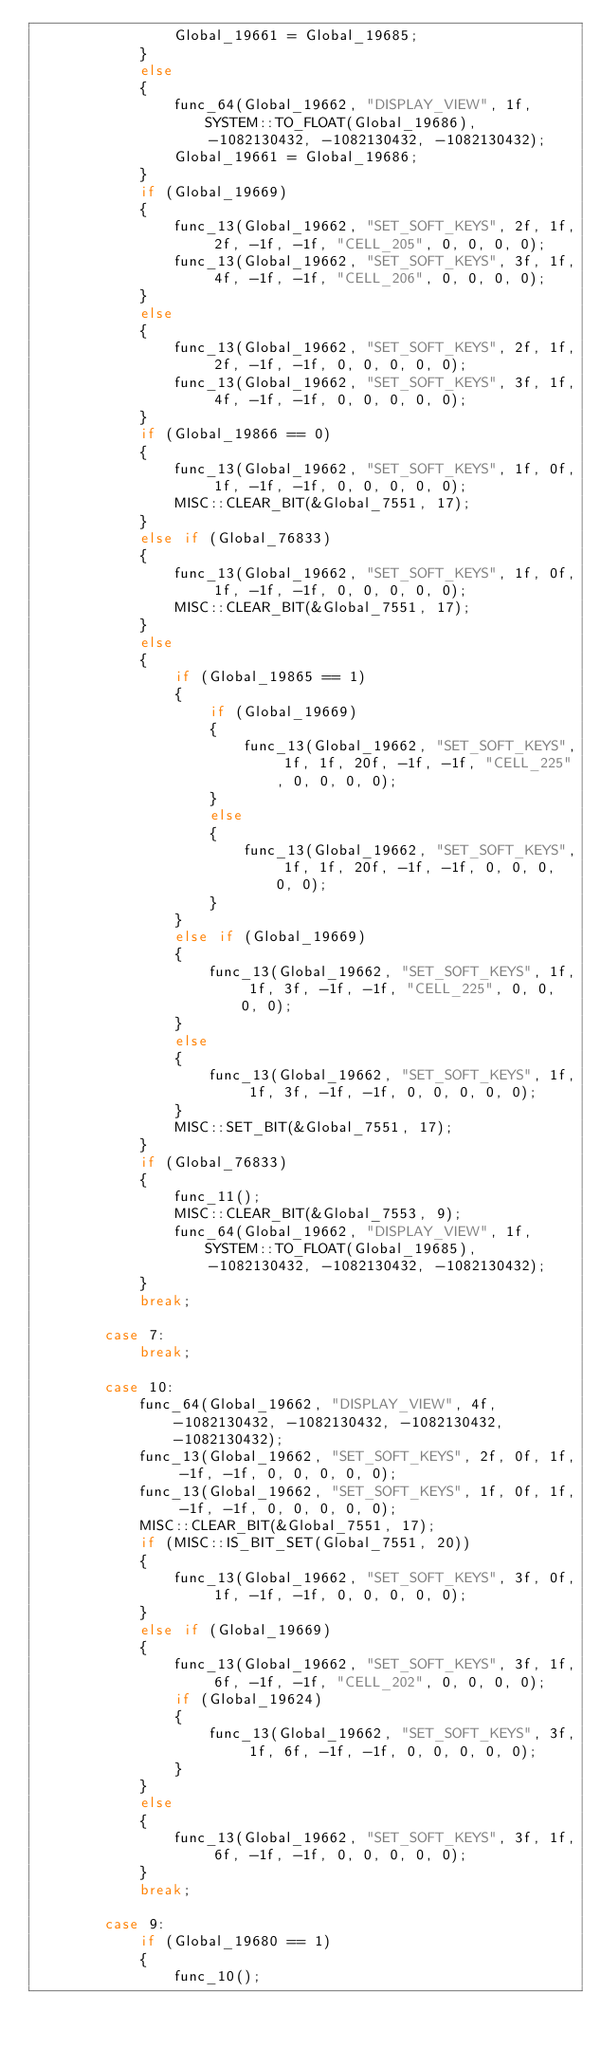Convert code to text. <code><loc_0><loc_0><loc_500><loc_500><_C_>				Global_19661 = Global_19685;
			}
			else
			{
				func_64(Global_19662, "DISPLAY_VIEW", 1f, SYSTEM::TO_FLOAT(Global_19686), -1082130432, -1082130432, -1082130432);
				Global_19661 = Global_19686;
			}
			if (Global_19669)
			{
				func_13(Global_19662, "SET_SOFT_KEYS", 2f, 1f, 2f, -1f, -1f, "CELL_205", 0, 0, 0, 0);
				func_13(Global_19662, "SET_SOFT_KEYS", 3f, 1f, 4f, -1f, -1f, "CELL_206", 0, 0, 0, 0);
			}
			else
			{
				func_13(Global_19662, "SET_SOFT_KEYS", 2f, 1f, 2f, -1f, -1f, 0, 0, 0, 0, 0);
				func_13(Global_19662, "SET_SOFT_KEYS", 3f, 1f, 4f, -1f, -1f, 0, 0, 0, 0, 0);
			}
			if (Global_19866 == 0)
			{
				func_13(Global_19662, "SET_SOFT_KEYS", 1f, 0f, 1f, -1f, -1f, 0, 0, 0, 0, 0);
				MISC::CLEAR_BIT(&Global_7551, 17);
			}
			else if (Global_76833)
			{
				func_13(Global_19662, "SET_SOFT_KEYS", 1f, 0f, 1f, -1f, -1f, 0, 0, 0, 0, 0);
				MISC::CLEAR_BIT(&Global_7551, 17);
			}
			else
			{
				if (Global_19865 == 1)
				{
					if (Global_19669)
					{
						func_13(Global_19662, "SET_SOFT_KEYS", 1f, 1f, 20f, -1f, -1f, "CELL_225", 0, 0, 0, 0);
					}
					else
					{
						func_13(Global_19662, "SET_SOFT_KEYS", 1f, 1f, 20f, -1f, -1f, 0, 0, 0, 0, 0);
					}
				}
				else if (Global_19669)
				{
					func_13(Global_19662, "SET_SOFT_KEYS", 1f, 1f, 3f, -1f, -1f, "CELL_225", 0, 0, 0, 0);
				}
				else
				{
					func_13(Global_19662, "SET_SOFT_KEYS", 1f, 1f, 3f, -1f, -1f, 0, 0, 0, 0, 0);
				}
				MISC::SET_BIT(&Global_7551, 17);
			}
			if (Global_76833)
			{
				func_11();
				MISC::CLEAR_BIT(&Global_7553, 9);
				func_64(Global_19662, "DISPLAY_VIEW", 1f, SYSTEM::TO_FLOAT(Global_19685), -1082130432, -1082130432, -1082130432);
			}
			break;
		
		case 7:
			break;
		
		case 10:
			func_64(Global_19662, "DISPLAY_VIEW", 4f, -1082130432, -1082130432, -1082130432, -1082130432);
			func_13(Global_19662, "SET_SOFT_KEYS", 2f, 0f, 1f, -1f, -1f, 0, 0, 0, 0, 0);
			func_13(Global_19662, "SET_SOFT_KEYS", 1f, 0f, 1f, -1f, -1f, 0, 0, 0, 0, 0);
			MISC::CLEAR_BIT(&Global_7551, 17);
			if (MISC::IS_BIT_SET(Global_7551, 20))
			{
				func_13(Global_19662, "SET_SOFT_KEYS", 3f, 0f, 1f, -1f, -1f, 0, 0, 0, 0, 0);
			}
			else if (Global_19669)
			{
				func_13(Global_19662, "SET_SOFT_KEYS", 3f, 1f, 6f, -1f, -1f, "CELL_202", 0, 0, 0, 0);
				if (Global_19624)
				{
					func_13(Global_19662, "SET_SOFT_KEYS", 3f, 1f, 6f, -1f, -1f, 0, 0, 0, 0, 0);
				}
			}
			else
			{
				func_13(Global_19662, "SET_SOFT_KEYS", 3f, 1f, 6f, -1f, -1f, 0, 0, 0, 0, 0);
			}
			break;
		
		case 9:
			if (Global_19680 == 1)
			{
				func_10();</code> 